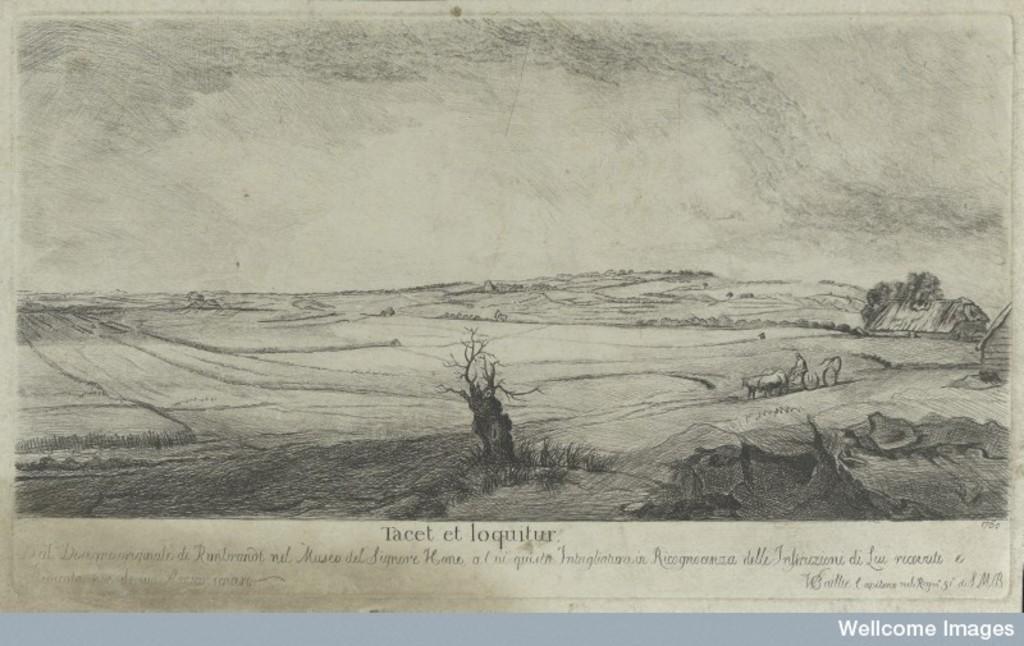Describe this image in one or two sentences. In this image I can see a paper, on the paper I can see dried trees, bullock cart and a house. I can see something written on the paper. 